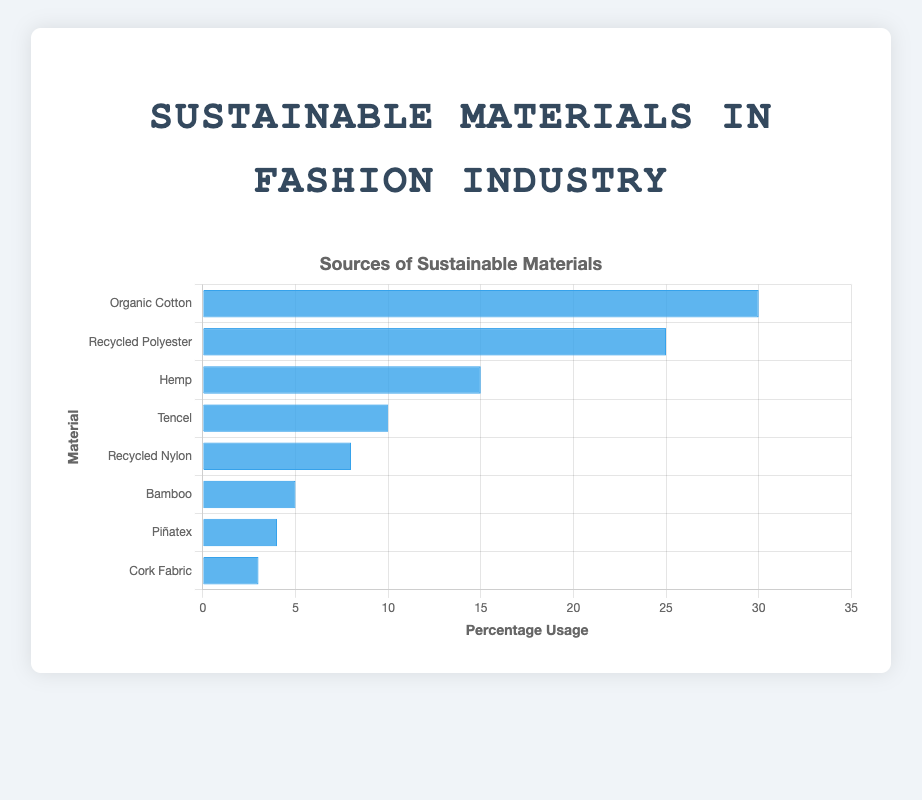Which material is used the most for sustainable fashion? Observing the bar chart, the tallest bar corresponds to 'Organic Cotton', which indicates that it has the highest percentage usage.
Answer: Organic Cotton Which material has the second highest usage in sustainable fashion? The second tallest bar on the chart represents 'Recycled Polyester', signifying it is the material with the second highest usage percentage.
Answer: Recycled Polyester How much more is Organic Cotton used compared to Bamboo? Organic Cotton usage is at 30%, while Bamboo is at 5%. The difference is calculated as 30% - 5% = 25%.
Answer: 25% What is the total percentage usage of Hemp and Recycled Nylon combined? Hemp usage is 15% and Recycled Nylon is 8%. Adding these gives 15% + 8% = 23%.
Answer: 23% Is Tencel used more or less than Hemp? Comparing the heights of the bars, Tencel (10%) is used less than Hemp (15%).
Answer: Less What is the average percentage usage of all the materials? Summing all the percentages: 30 + 25 + 15 + 10 + 8 + 5 + 4 + 3 = 100. There are 8 materials. Thus, the average usage is 100 ÷ 8 = 12.5.
Answer: 12.5% How does the usage of Piñatex compare to the usage of Cork Fabric? The usage of Piñatex (4%) is greater than that of Cork Fabric (3%).
Answer: Greater Which material sources contribute to a combined total usage of more than 20%? The materials whose individual percentages sum up to more than 20% are Organic Cotton (30%), Recycled Polyester (25%), and Hemp (15%) individually. However, Recycled Nylon (8%), Bamboo (5%), Piñatex (4%), and Cork Fabric (3%) do not exceed 20%.
Answer: Organic Cotton, Recycled Polyester, Hemp If the usage of Recycled Polyester increased by 10%, what would be the new combined percentage usage of Organic Cotton and Recycled Polyester? If Recycled Polyester usage increases by 10%, its new usage would be 25% + 10% = 35%. The combined usage with Organic Cotton would be 30% + 35% = 65%.
Answer: 65% 